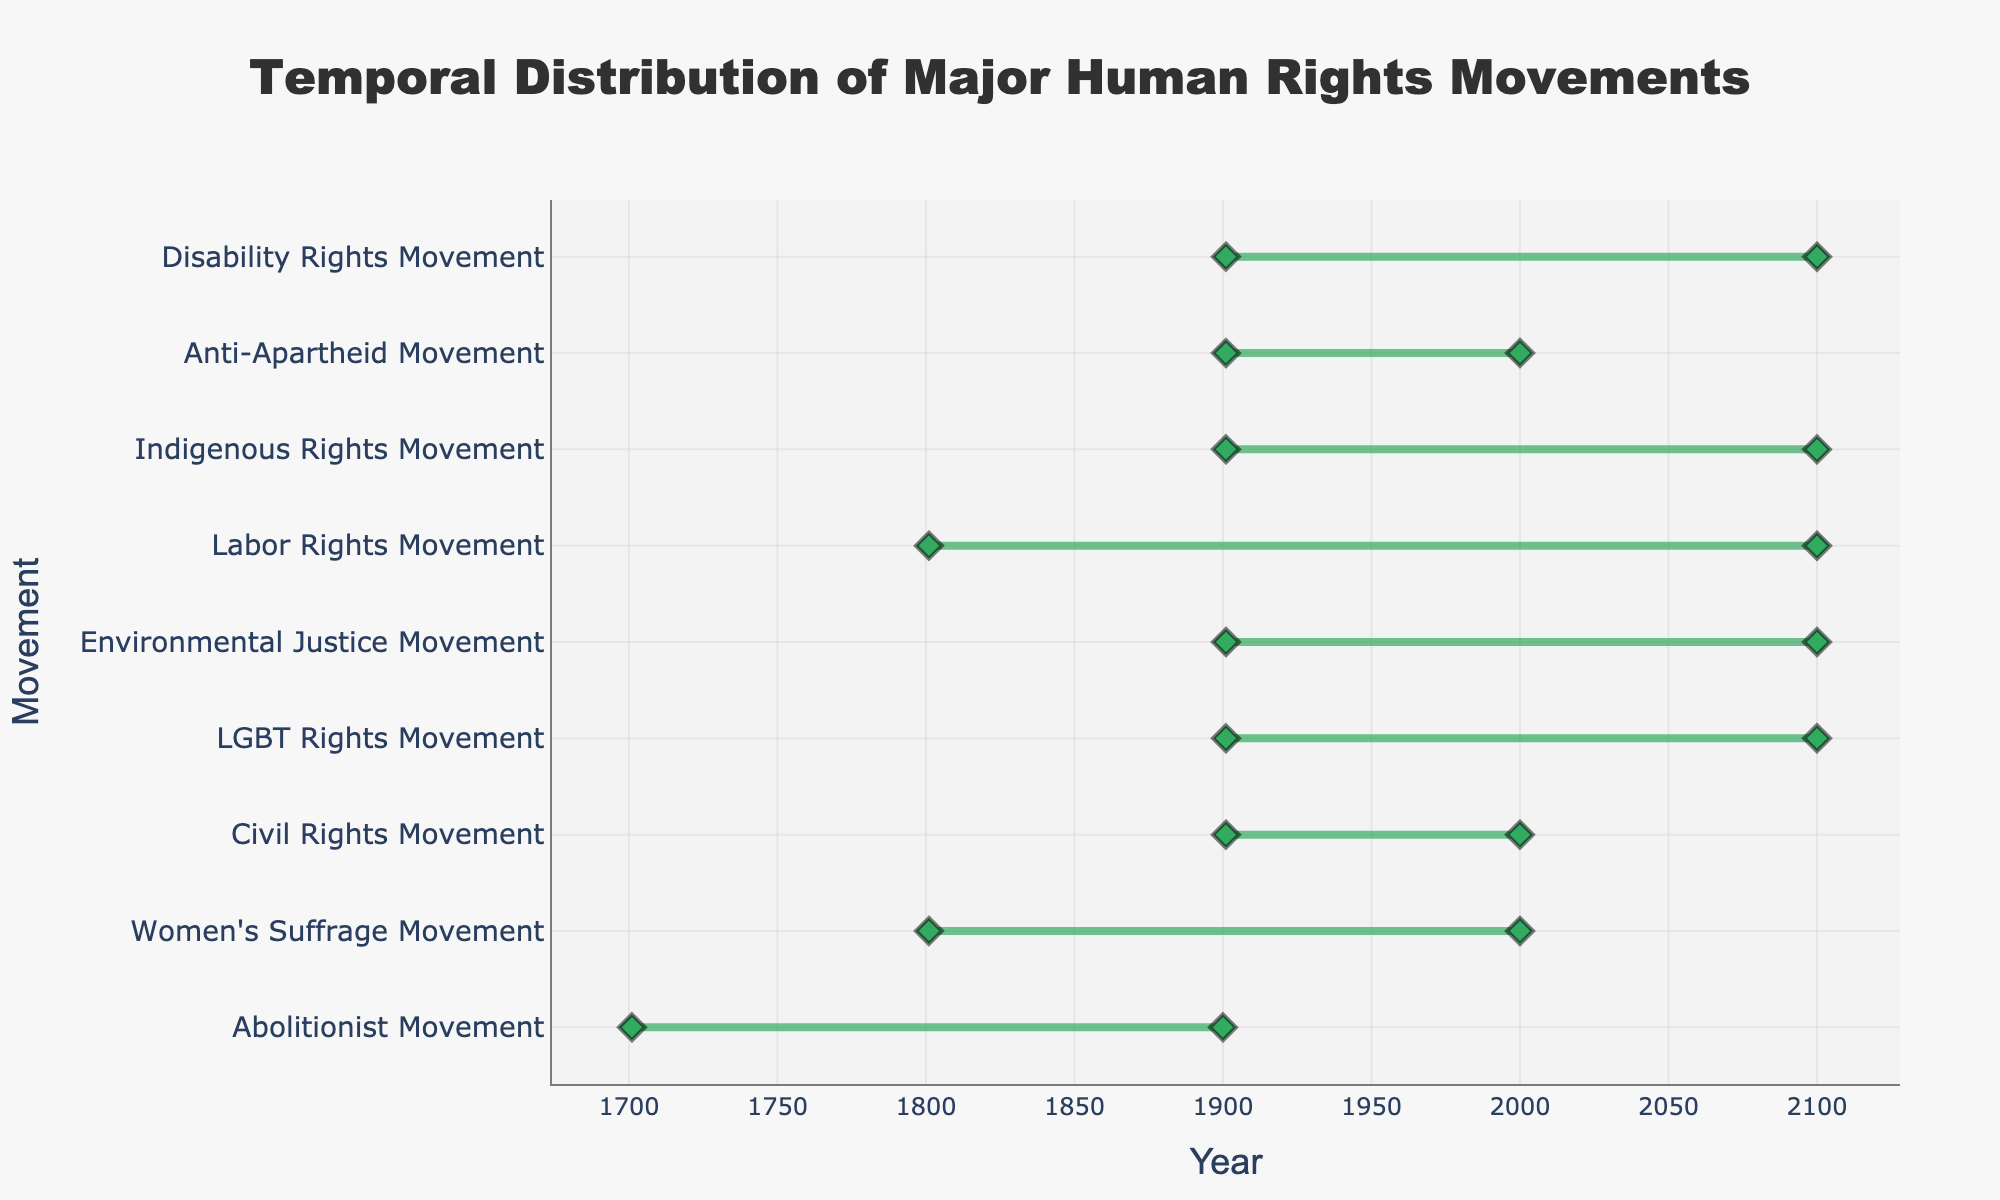Which century does the figure's title refer to? The title of the figure states "Temporal Distribution of Major Human Rights Movements," focusing on the involved centuries. From the x-axis, we can observe that the data ranges from the 18th to the 21st century.
Answer: 18th to 21st century Which movement started earliest according to the plot? By looking at the leftmost end of the plot, we can see that the Abolitionist Movement started in the 18th century, making it the earliest movement represented.
Answer: Abolitionist Movement Which rights movements span across both the 20th and 21st centuries? Observing the plot, the movements that span across both the 20th and 21st centuries are the LGBT Rights Movement, Environmental Justice Movement, Labor Rights Movement, Indigenous Rights Movement, and Disability Rights Movement.
Answer: LGBT Rights Movement, Environmental Justice Movement, Labor Rights Movement, Indigenous Rights Movement, Disability Rights Movement Which movement has the shortest duration according to the plot? By comparing the lengths of the lines representing each movement, we see that the Anti-Apartheid Movement spans the shortest duration, only in the 20th century.
Answer: Anti-Apartheid Movement On average, in which century did the movements begin? Considering the start years: Abolitionist (18th), Women's Suffrage (19th), Civil Rights (20th), LGBT Rights (20th), Environmental Justice (20th), Labor Rights (19th), Indigenous Rights (20th), Anti-Apartheid (20th), Disability Rights (20th). Calculating the average of these start centuries: (18 + 19 + 20 + 20 + 20 + 19 + 20 + 20 + 20)/9 = 19.56, which rounds to 20th century.
Answer: 20th century How many movements are depicted with lines that start in the 20th century? Identifying the lines that begin in or after the 20th century, we count the Civil Rights Movement, LGBT Rights Movement, Environmental Justice Movement, Indigenous Rights Movement, Anti-Apartheid Movement, and Disability Rights Movement. Also including those from the 19th which continue into the 20th, Labor Rights Movement. In total, there are 7 movements.
Answer: 7 Which century contains the highest number of movements mentioned in the figure? Observing the plot, the 20th century includes almost all the movements: Women's Suffrage, Civil Rights, LGBT Rights, Environmental Justice, Labor Rights, Indigenous Rights, Anti-Apartheid, and Disability Rights.
Answer: 20th century Which movement ends the latest according to the plot? By looking at the farthest right ends of the lines, we see that the movements ending last include the LGBT Rights Movement, Environmental Justice Movement, Labor Rights Movement, Indigenous Rights Movement, and Disability Rights Movement as they extend into the 21st century.
Answer: LGBT Rights Movement, Environmental Justice Movement, Labor Rights Movement, Indigenous Rights Movement, Disability Rights Movement 